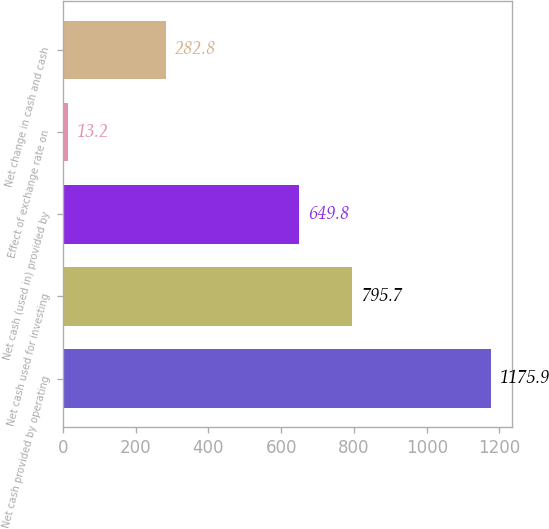Convert chart to OTSL. <chart><loc_0><loc_0><loc_500><loc_500><bar_chart><fcel>Net cash provided by operating<fcel>Net cash used for investing<fcel>Net cash (used in) provided by<fcel>Effect of exchange rate on<fcel>Net change in cash and cash<nl><fcel>1175.9<fcel>795.7<fcel>649.8<fcel>13.2<fcel>282.8<nl></chart> 